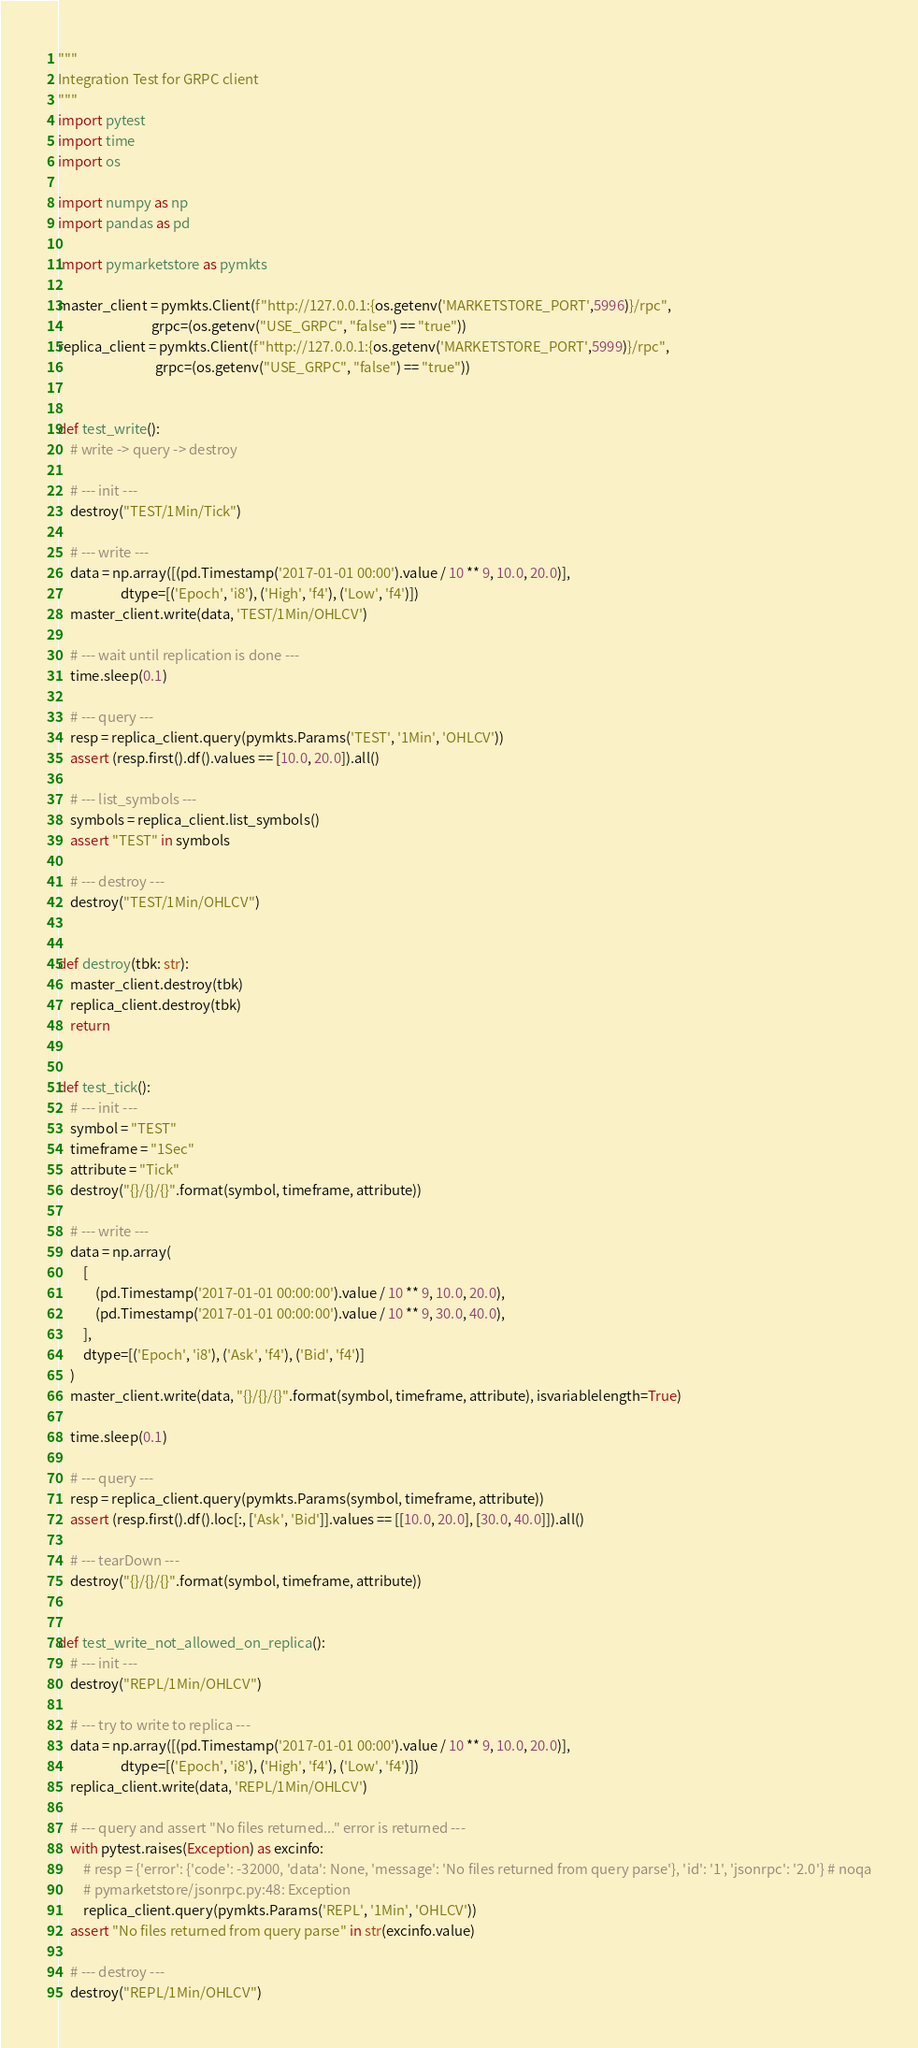<code> <loc_0><loc_0><loc_500><loc_500><_Python_>"""
Integration Test for GRPC client
"""
import pytest
import time
import os

import numpy as np
import pandas as pd

import pymarketstore as pymkts

master_client = pymkts.Client(f"http://127.0.0.1:{os.getenv('MARKETSTORE_PORT',5996)}/rpc",
                              grpc=(os.getenv("USE_GRPC", "false") == "true"))
replica_client = pymkts.Client(f"http://127.0.0.1:{os.getenv('MARKETSTORE_PORT',5999)}/rpc",
                               grpc=(os.getenv("USE_GRPC", "false") == "true"))


def test_write():
    # write -> query -> destroy

    # --- init ---
    destroy("TEST/1Min/Tick")

    # --- write ---
    data = np.array([(pd.Timestamp('2017-01-01 00:00').value / 10 ** 9, 10.0, 20.0)],
                    dtype=[('Epoch', 'i8'), ('High', 'f4'), ('Low', 'f4')])
    master_client.write(data, 'TEST/1Min/OHLCV')

    # --- wait until replication is done ---
    time.sleep(0.1)

    # --- query ---
    resp = replica_client.query(pymkts.Params('TEST', '1Min', 'OHLCV'))
    assert (resp.first().df().values == [10.0, 20.0]).all()

    # --- list_symbols ---
    symbols = replica_client.list_symbols()
    assert "TEST" in symbols

    # --- destroy ---
    destroy("TEST/1Min/OHLCV")


def destroy(tbk: str):
    master_client.destroy(tbk)
    replica_client.destroy(tbk)
    return


def test_tick():
    # --- init ---
    symbol = "TEST"
    timeframe = "1Sec"
    attribute = "Tick"
    destroy("{}/{}/{}".format(symbol, timeframe, attribute))

    # --- write ---
    data = np.array(
        [
            (pd.Timestamp('2017-01-01 00:00:00').value / 10 ** 9, 10.0, 20.0),
            (pd.Timestamp('2017-01-01 00:00:00').value / 10 ** 9, 30.0, 40.0),
        ],
        dtype=[('Epoch', 'i8'), ('Ask', 'f4'), ('Bid', 'f4')]
    )
    master_client.write(data, "{}/{}/{}".format(symbol, timeframe, attribute), isvariablelength=True)

    time.sleep(0.1)

    # --- query ---
    resp = replica_client.query(pymkts.Params(symbol, timeframe, attribute))
    assert (resp.first().df().loc[:, ['Ask', 'Bid']].values == [[10.0, 20.0], [30.0, 40.0]]).all()

    # --- tearDown ---
    destroy("{}/{}/{}".format(symbol, timeframe, attribute))


def test_write_not_allowed_on_replica():
    # --- init ---
    destroy("REPL/1Min/OHLCV")

    # --- try to write to replica ---
    data = np.array([(pd.Timestamp('2017-01-01 00:00').value / 10 ** 9, 10.0, 20.0)],
                    dtype=[('Epoch', 'i8'), ('High', 'f4'), ('Low', 'f4')])
    replica_client.write(data, 'REPL/1Min/OHLCV')

    # --- query and assert "No files returned..." error is returned ---
    with pytest.raises(Exception) as excinfo:
        # resp = {'error': {'code': -32000, 'data': None, 'message': 'No files returned from query parse'}, 'id': '1', 'jsonrpc': '2.0'} # noqa
        # pymarketstore/jsonrpc.py:48: Exception
        replica_client.query(pymkts.Params('REPL', '1Min', 'OHLCV'))
    assert "No files returned from query parse" in str(excinfo.value)

    # --- destroy ---
    destroy("REPL/1Min/OHLCV")
</code> 